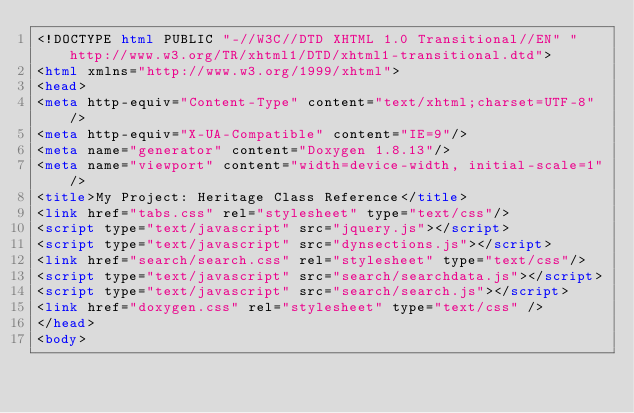Convert code to text. <code><loc_0><loc_0><loc_500><loc_500><_HTML_><!DOCTYPE html PUBLIC "-//W3C//DTD XHTML 1.0 Transitional//EN" "http://www.w3.org/TR/xhtml1/DTD/xhtml1-transitional.dtd">
<html xmlns="http://www.w3.org/1999/xhtml">
<head>
<meta http-equiv="Content-Type" content="text/xhtml;charset=UTF-8"/>
<meta http-equiv="X-UA-Compatible" content="IE=9"/>
<meta name="generator" content="Doxygen 1.8.13"/>
<meta name="viewport" content="width=device-width, initial-scale=1"/>
<title>My Project: Heritage Class Reference</title>
<link href="tabs.css" rel="stylesheet" type="text/css"/>
<script type="text/javascript" src="jquery.js"></script>
<script type="text/javascript" src="dynsections.js"></script>
<link href="search/search.css" rel="stylesheet" type="text/css"/>
<script type="text/javascript" src="search/searchdata.js"></script>
<script type="text/javascript" src="search/search.js"></script>
<link href="doxygen.css" rel="stylesheet" type="text/css" />
</head>
<body></code> 